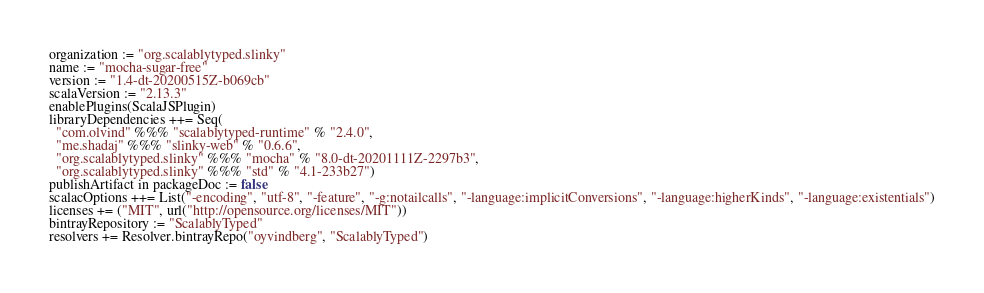<code> <loc_0><loc_0><loc_500><loc_500><_Scala_>organization := "org.scalablytyped.slinky"
name := "mocha-sugar-free"
version := "1.4-dt-20200515Z-b069cb"
scalaVersion := "2.13.3"
enablePlugins(ScalaJSPlugin)
libraryDependencies ++= Seq(
  "com.olvind" %%% "scalablytyped-runtime" % "2.4.0",
  "me.shadaj" %%% "slinky-web" % "0.6.6",
  "org.scalablytyped.slinky" %%% "mocha" % "8.0-dt-20201111Z-2297b3",
  "org.scalablytyped.slinky" %%% "std" % "4.1-233b27")
publishArtifact in packageDoc := false
scalacOptions ++= List("-encoding", "utf-8", "-feature", "-g:notailcalls", "-language:implicitConversions", "-language:higherKinds", "-language:existentials")
licenses += ("MIT", url("http://opensource.org/licenses/MIT"))
bintrayRepository := "ScalablyTyped"
resolvers += Resolver.bintrayRepo("oyvindberg", "ScalablyTyped")
</code> 